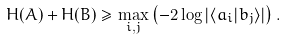Convert formula to latex. <formula><loc_0><loc_0><loc_500><loc_500>H ( A ) + H ( B ) \geq \max _ { i , j } \left ( - 2 \log | \langle a _ { i } | b _ { j } \rangle | \right ) .</formula> 